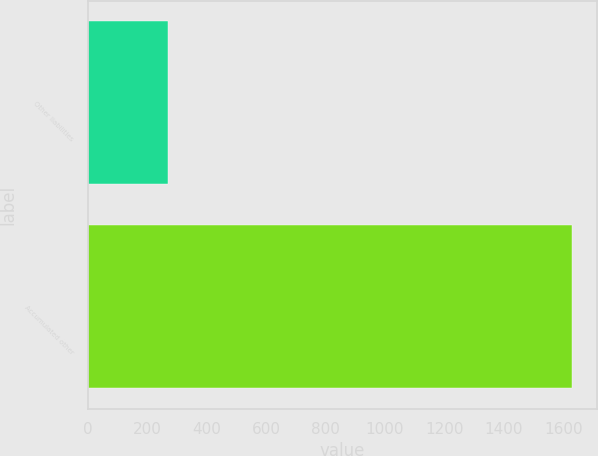Convert chart. <chart><loc_0><loc_0><loc_500><loc_500><bar_chart><fcel>Other liabilities<fcel>Accumulated other<nl><fcel>269<fcel>1631<nl></chart> 